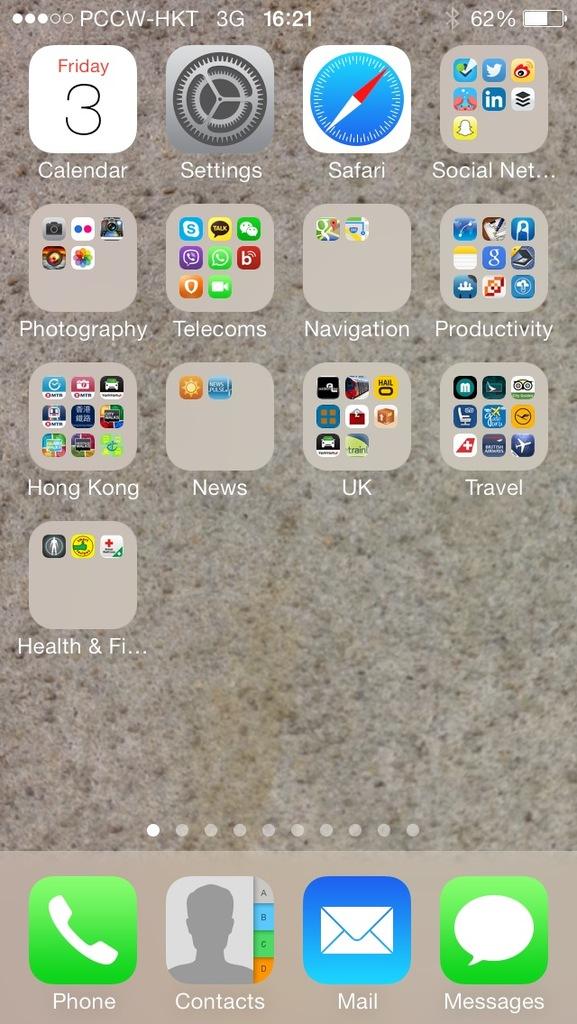What day is it according to this phone?
Ensure brevity in your answer.  Friday. What time does the iphone stay at the top?
Keep it short and to the point. 16:21. 